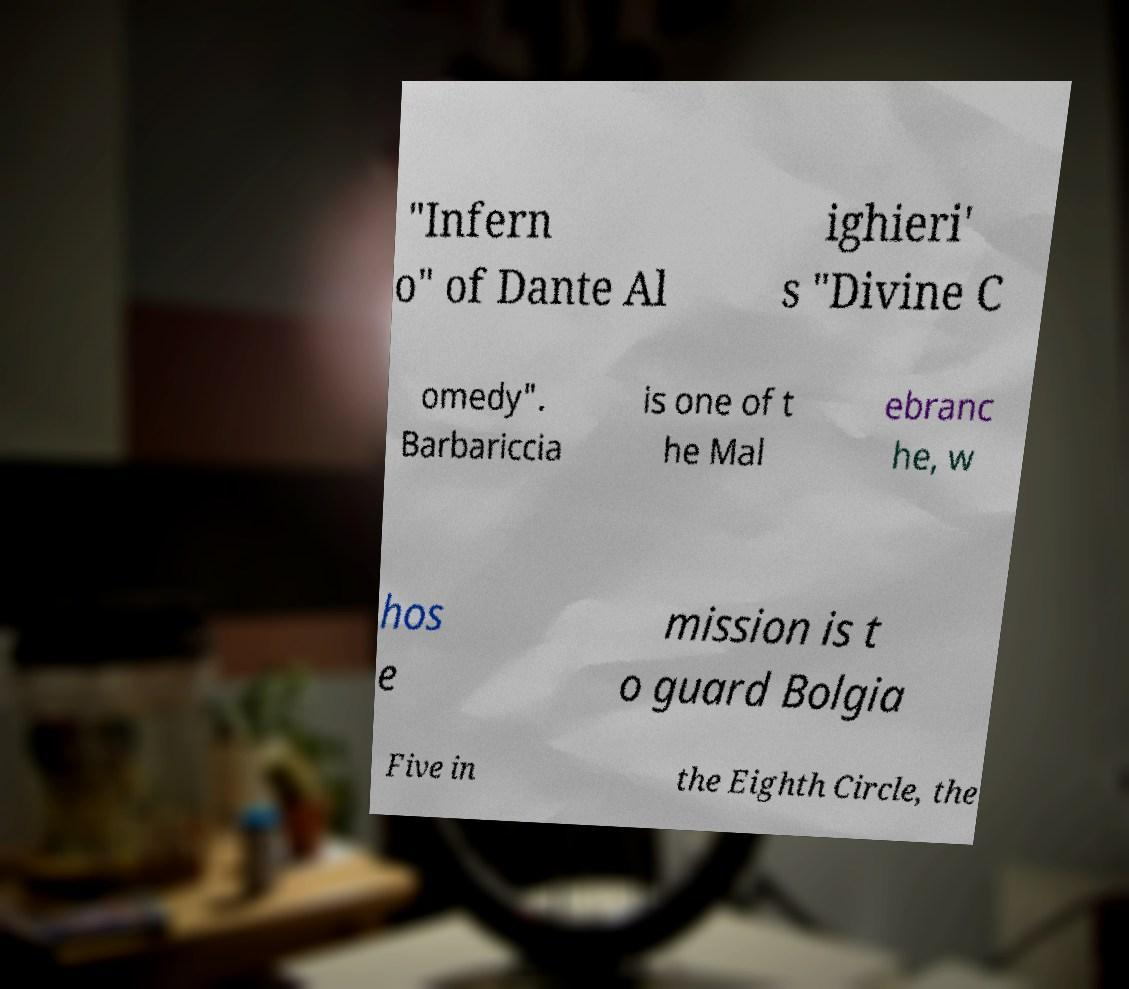For documentation purposes, I need the text within this image transcribed. Could you provide that? "Infern o" of Dante Al ighieri' s "Divine C omedy". Barbariccia is one of t he Mal ebranc he, w hos e mission is t o guard Bolgia Five in the Eighth Circle, the 